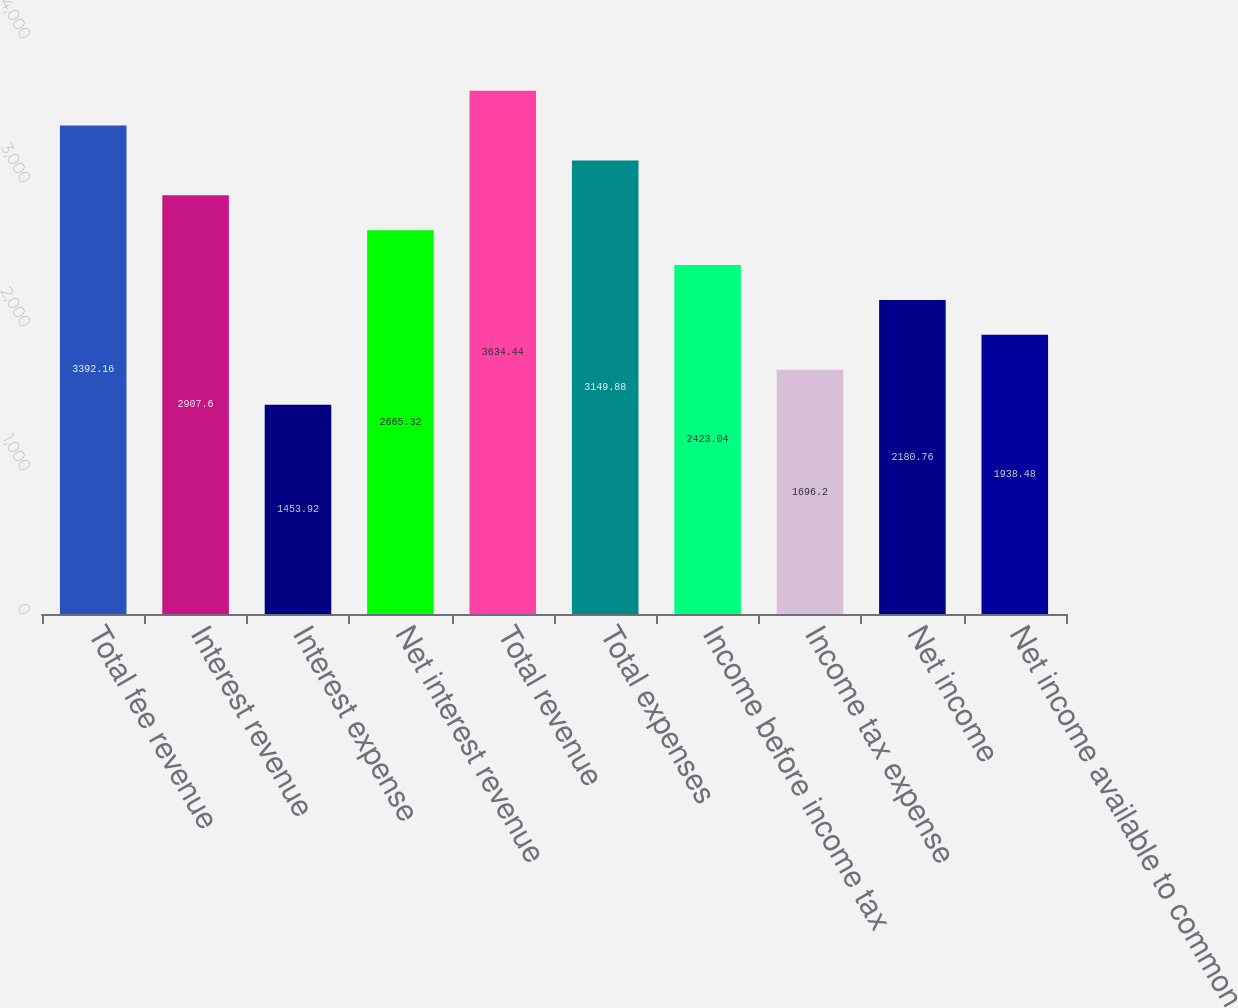Convert chart. <chart><loc_0><loc_0><loc_500><loc_500><bar_chart><fcel>Total fee revenue<fcel>Interest revenue<fcel>Interest expense<fcel>Net interest revenue<fcel>Total revenue<fcel>Total expenses<fcel>Income before income tax<fcel>Income tax expense<fcel>Net income<fcel>Net income available to common<nl><fcel>3392.16<fcel>2907.6<fcel>1453.92<fcel>2665.32<fcel>3634.44<fcel>3149.88<fcel>2423.04<fcel>1696.2<fcel>2180.76<fcel>1938.48<nl></chart> 